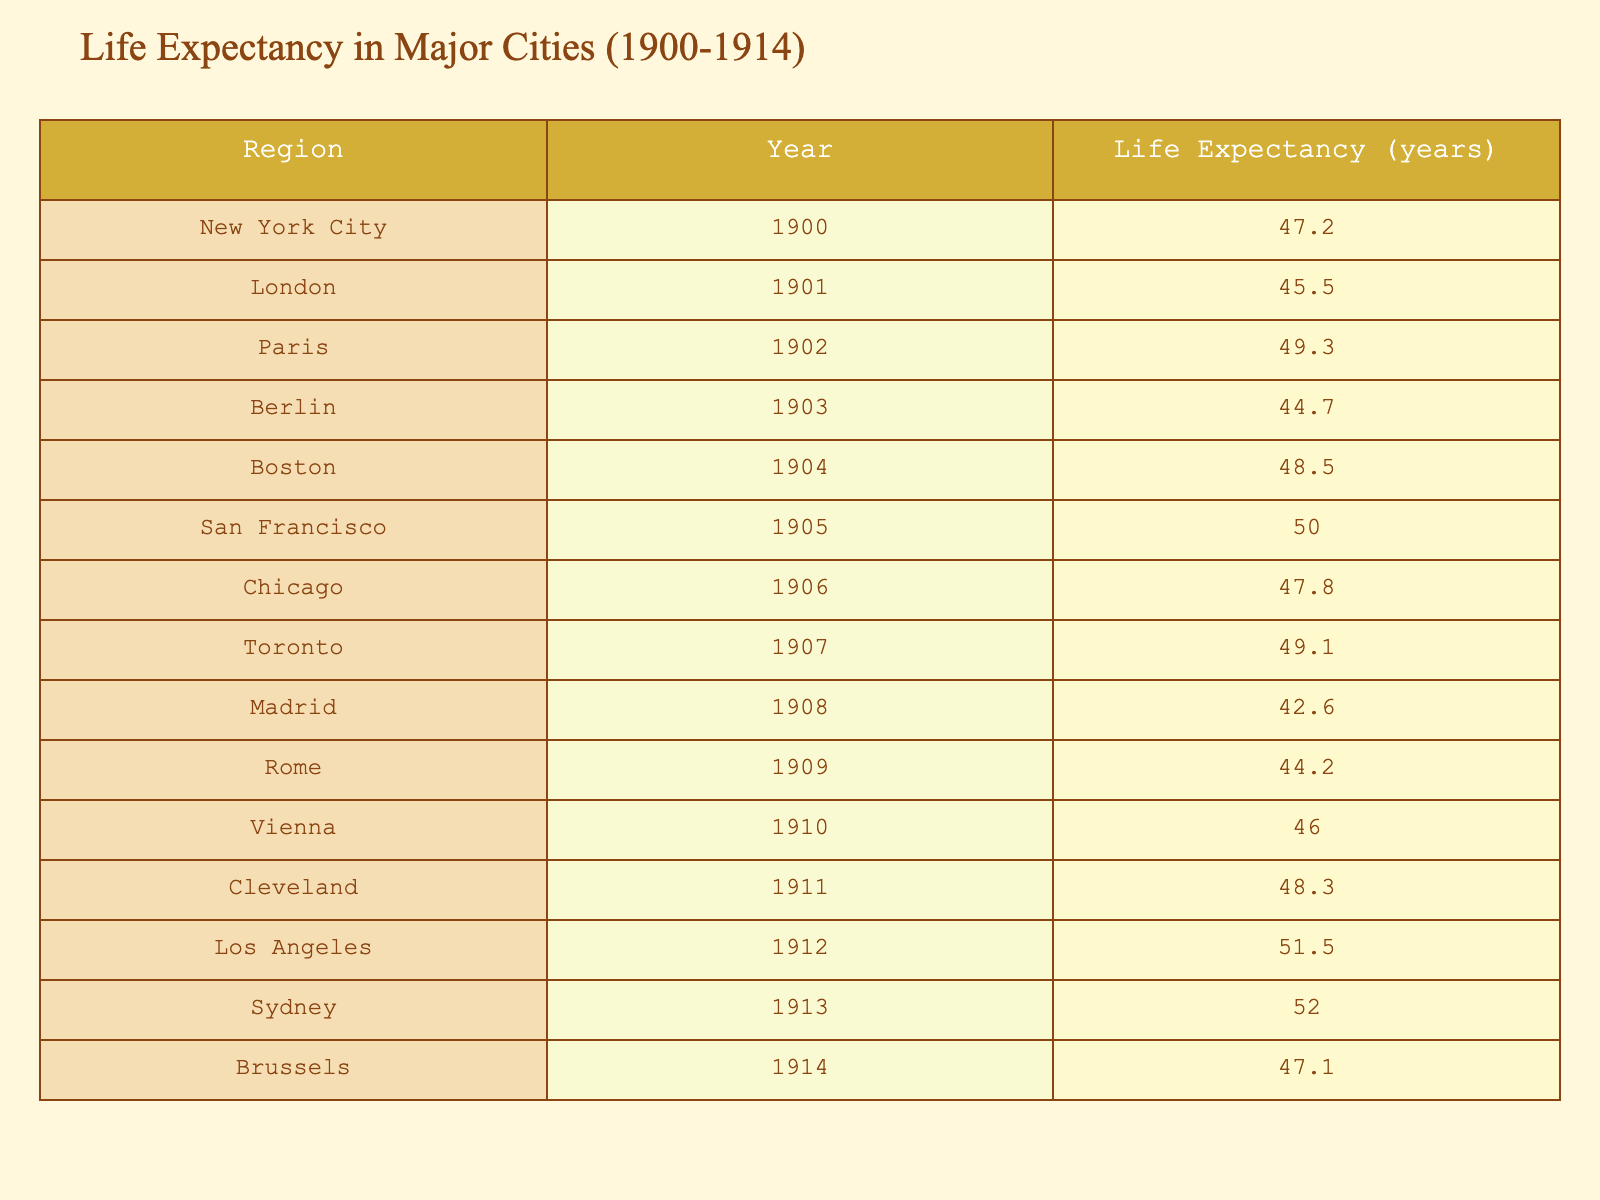What is the life expectancy in San Francisco in 1905? The table lists the life expectancy for various regions and years. For San Francisco in the year 1905, the corresponding value is directly available in the table.
Answer: 50.0 Which city had the lowest life expectancy recorded in the table? By examining the life expectancy values for each city in the table, Madrid in 1908 had the lowest value of 42.6 years.
Answer: Madrid What is the average life expectancy of cities listed from 1900 to 1905? The life expectancy values for the years 1900 to 1905 are as follows: 47.2 (New York City), 45.5 (London), 49.3 (Paris), 48.5 (Boston), and 50.0 (San Francisco). Summing these values gives 240.5. There are 5 cities, so the average is 240.5 divided by 5, which equals 48.1 years.
Answer: 48.1 Is the life expectancy in Paris greater than that in Berlin? From the table, Paris in 1902 has a life expectancy of 49.3 years, while Berlin in 1903 has 44.7 years. Since 49.3 is greater than 44.7, the statement is true.
Answer: Yes Which city saw the highest life expectancy in the year 1913? The table indicates that in 1913, Sydney had a life expectancy of 52.0 years, which is the highest life expectancy of any city listed in the table for that year.
Answer: Sydney 